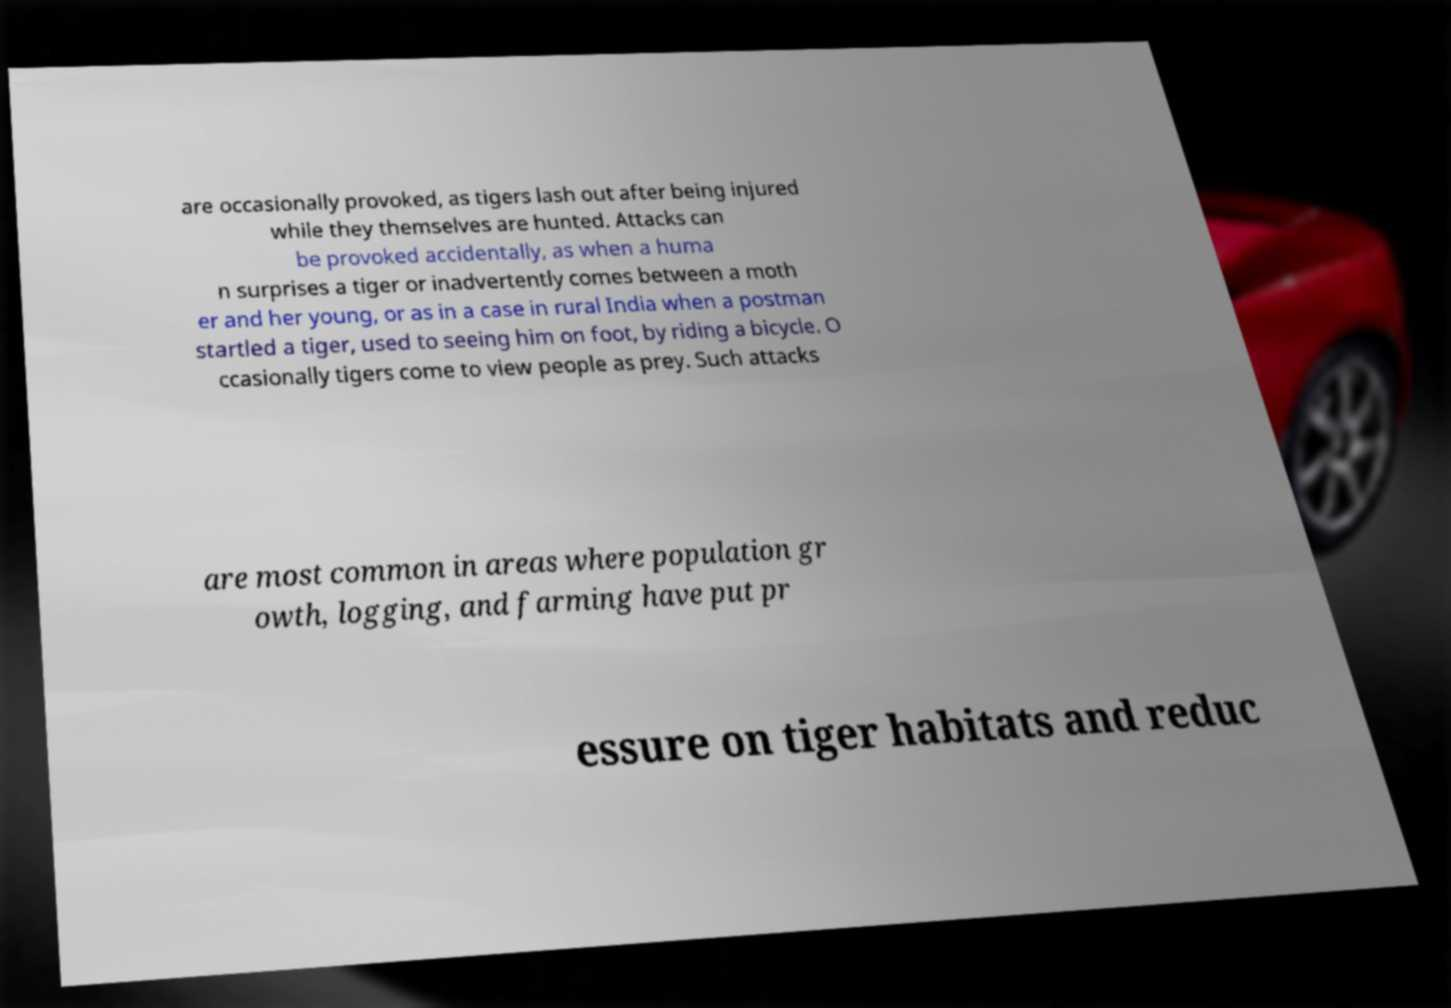Please read and relay the text visible in this image. What does it say? are occasionally provoked, as tigers lash out after being injured while they themselves are hunted. Attacks can be provoked accidentally, as when a huma n surprises a tiger or inadvertently comes between a moth er and her young, or as in a case in rural India when a postman startled a tiger, used to seeing him on foot, by riding a bicycle. O ccasionally tigers come to view people as prey. Such attacks are most common in areas where population gr owth, logging, and farming have put pr essure on tiger habitats and reduc 